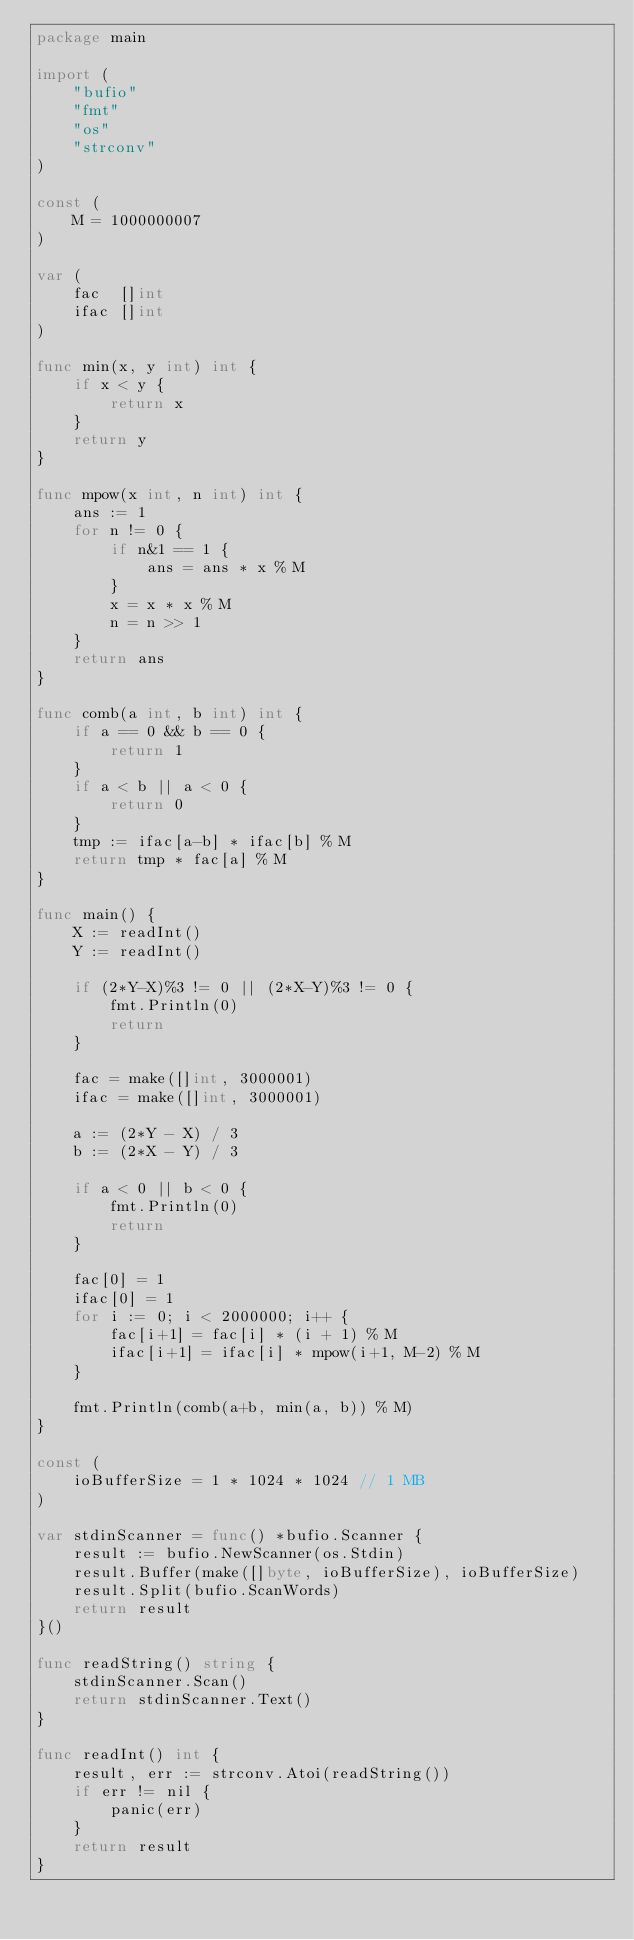<code> <loc_0><loc_0><loc_500><loc_500><_Go_>package main

import (
	"bufio"
	"fmt"
	"os"
	"strconv"
)

const (
	M = 1000000007
)

var (
	fac  []int
	ifac []int
)

func min(x, y int) int {
	if x < y {
		return x
	}
	return y
}

func mpow(x int, n int) int {
	ans := 1
	for n != 0 {
		if n&1 == 1 {
			ans = ans * x % M
		}
		x = x * x % M
		n = n >> 1
	}
	return ans
}

func comb(a int, b int) int {
	if a == 0 && b == 0 {
		return 1
	}
	if a < b || a < 0 {
		return 0
	}
	tmp := ifac[a-b] * ifac[b] % M
	return tmp * fac[a] % M
}

func main() {
	X := readInt()
	Y := readInt()

	if (2*Y-X)%3 != 0 || (2*X-Y)%3 != 0 {
		fmt.Println(0)
		return
	}

	fac = make([]int, 3000001)
	ifac = make([]int, 3000001)

	a := (2*Y - X) / 3
	b := (2*X - Y) / 3

	if a < 0 || b < 0 {
		fmt.Println(0)
		return
	}

	fac[0] = 1
	ifac[0] = 1
	for i := 0; i < 2000000; i++ {
		fac[i+1] = fac[i] * (i + 1) % M
		ifac[i+1] = ifac[i] * mpow(i+1, M-2) % M
	}

	fmt.Println(comb(a+b, min(a, b)) % M)
}

const (
	ioBufferSize = 1 * 1024 * 1024 // 1 MB
)

var stdinScanner = func() *bufio.Scanner {
	result := bufio.NewScanner(os.Stdin)
	result.Buffer(make([]byte, ioBufferSize), ioBufferSize)
	result.Split(bufio.ScanWords)
	return result
}()

func readString() string {
	stdinScanner.Scan()
	return stdinScanner.Text()
}

func readInt() int {
	result, err := strconv.Atoi(readString())
	if err != nil {
		panic(err)
	}
	return result
}
</code> 